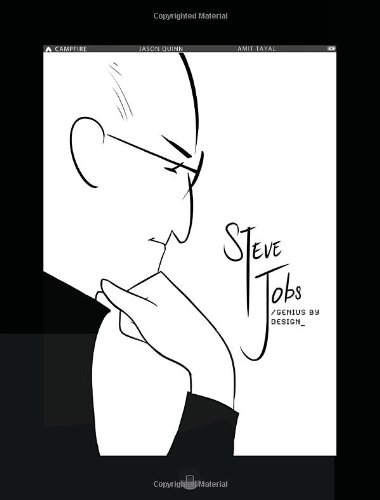What is the genre of this book? This book encompasses genres like children's books, graphic novels, and biographies, tailored to engage young minds with rich illustrations and compelling narratives. 